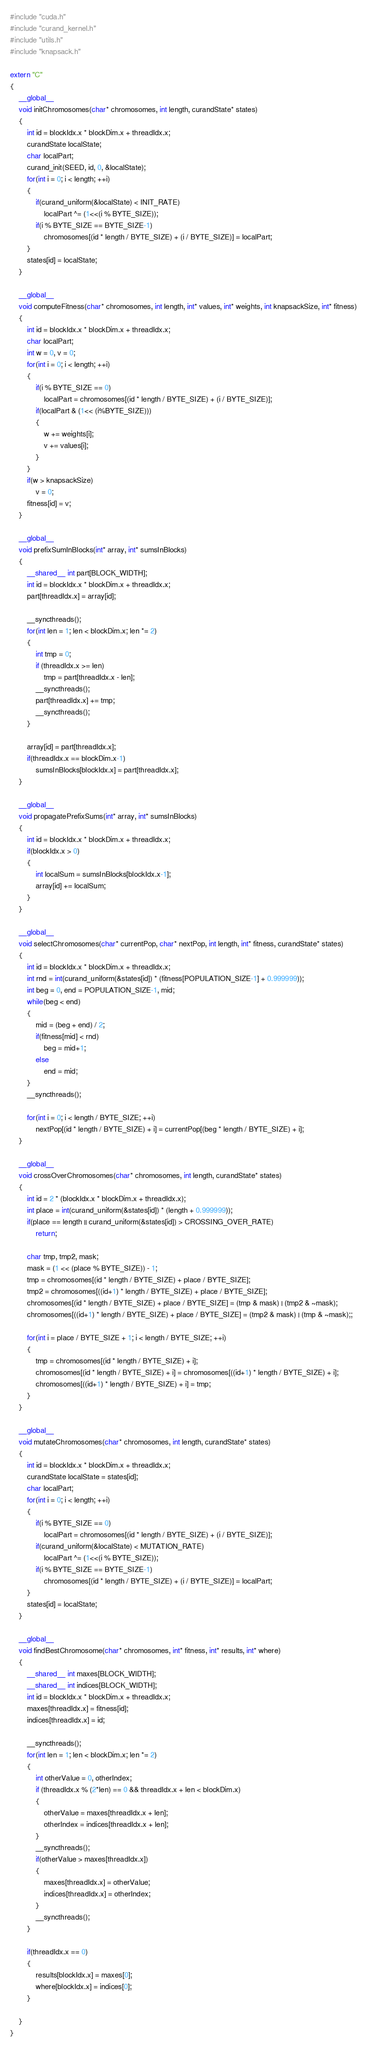Convert code to text. <code><loc_0><loc_0><loc_500><loc_500><_Cuda_>#include "cuda.h"
#include "curand_kernel.h"
#include "utils.h"
#include "knapsack.h"

extern "C"
{
    __global__
    void initChromosomes(char* chromosomes, int length, curandState* states)
    {
        int id = blockIdx.x * blockDim.x + threadIdx.x;
        curandState localState;
        char localPart;
        curand_init(SEED, id, 0, &localState);
        for(int i = 0; i < length; ++i)
        {
            if(curand_uniform(&localState) < INIT_RATE)
                localPart ^= (1<<(i % BYTE_SIZE));
            if(i % BYTE_SIZE == BYTE_SIZE-1)
                chromosomes[(id * length / BYTE_SIZE) + (i / BYTE_SIZE)] = localPart;
        }
        states[id] = localState;
    }

    __global__
    void computeFitness(char* chromosomes, int length, int* values, int* weights, int knapsackSize, int* fitness)
    {
        int id = blockIdx.x * blockDim.x + threadIdx.x;
        char localPart;
        int w = 0, v = 0;
        for(int i = 0; i < length; ++i)
        {
            if(i % BYTE_SIZE == 0)
                localPart = chromosomes[(id * length / BYTE_SIZE) + (i / BYTE_SIZE)];
            if(localPart & (1<< (i%BYTE_SIZE)))
            {
                w += weights[i];
                v += values[i];
            }
        }
        if(w > knapsackSize)
            v = 0;
        fitness[id] = v;
    }

    __global__
    void prefixSumInBlocks(int* array, int* sumsInBlocks)
    {
        __shared__ int part[BLOCK_WIDTH];
        int id = blockIdx.x * blockDim.x + threadIdx.x;
        part[threadIdx.x] = array[id];
        
        __syncthreads();
        for(int len = 1; len < blockDim.x; len *= 2)
        {
            int tmp = 0;
            if (threadIdx.x >= len)
                tmp = part[threadIdx.x - len];
            __syncthreads();
            part[threadIdx.x] += tmp;
            __syncthreads();
        }

        array[id] = part[threadIdx.x];
        if(threadIdx.x == blockDim.x-1)
            sumsInBlocks[blockIdx.x] = part[threadIdx.x];
    }

    __global__
    void propagatePrefixSums(int* array, int* sumsInBlocks)
    {
        int id = blockIdx.x * blockDim.x + threadIdx.x;
        if(blockIdx.x > 0)
        {
            int localSum = sumsInBlocks[blockIdx.x-1];
            array[id] += localSum;
        }
    }

    __global__
    void selectChromosomes(char* currentPop, char* nextPop, int length, int* fitness, curandState* states)
    {
        int id = blockIdx.x * blockDim.x + threadIdx.x;
        int rnd = int(curand_uniform(&states[id]) * (fitness[POPULATION_SIZE-1] + 0.999999));
        int beg = 0, end = POPULATION_SIZE-1, mid;
        while(beg < end)
        {
            mid = (beg + end) / 2;
            if(fitness[mid] < rnd)
                beg = mid+1;
            else
                end = mid;
        }
        __syncthreads();

        for(int i = 0; i < length / BYTE_SIZE; ++i)
            nextPop[(id * length / BYTE_SIZE) + i] = currentPop[(beg * length / BYTE_SIZE) + i];
    }

    __global__
    void crossOverChromosomes(char* chromosomes, int length, curandState* states)
    {
        int id = 2 * (blockIdx.x * blockDim.x + threadIdx.x);
        int place = int(curand_uniform(&states[id]) * (length + 0.999999));
        if(place == length || curand_uniform(&states[id]) > CROSSING_OVER_RATE)
            return;

        char tmp, tmp2, mask;
        mask = (1 << (place % BYTE_SIZE)) - 1;
        tmp = chromosomes[(id * length / BYTE_SIZE) + place / BYTE_SIZE];
        tmp2 = chromosomes[((id+1) * length / BYTE_SIZE) + place / BYTE_SIZE];
        chromosomes[(id * length / BYTE_SIZE) + place / BYTE_SIZE] = (tmp & mask) | (tmp2 & ~mask);
        chromosomes[((id+1) * length / BYTE_SIZE) + place / BYTE_SIZE] = (tmp2 & mask) | (tmp & ~mask);;

        for(int i = place / BYTE_SIZE + 1; i < length / BYTE_SIZE; ++i)
        {
            tmp = chromosomes[(id * length / BYTE_SIZE) + i];
            chromosomes[(id * length / BYTE_SIZE) + i] = chromosomes[((id+1) * length / BYTE_SIZE) + i];
            chromosomes[((id+1) * length / BYTE_SIZE) + i] = tmp;
        }
    }

    __global__
    void mutateChromosomes(char* chromosomes, int length, curandState* states)
    {
        int id = blockIdx.x * blockDim.x + threadIdx.x;
        curandState localState = states[id];
        char localPart;
        for(int i = 0; i < length; ++i)
        {
            if(i % BYTE_SIZE == 0)
                localPart = chromosomes[(id * length / BYTE_SIZE) + (i / BYTE_SIZE)];
            if(curand_uniform(&localState) < MUTATION_RATE)
                localPart ^= (1<<(i % BYTE_SIZE));
            if(i % BYTE_SIZE == BYTE_SIZE-1)
                chromosomes[(id * length / BYTE_SIZE) + (i / BYTE_SIZE)] = localPart;
        }
        states[id] = localState;
    }

    __global__
    void findBestChromosome(char* chromosomes, int* fitness, int* results, int* where)
    {
        __shared__ int maxes[BLOCK_WIDTH];
        __shared__ int indices[BLOCK_WIDTH];
        int id = blockIdx.x * blockDim.x + threadIdx.x;
        maxes[threadIdx.x] = fitness[id];
        indices[threadIdx.x] = id;
        
        __syncthreads();
        for(int len = 1; len < blockDim.x; len *= 2)
        {
            int otherValue = 0, otherIndex;
            if (threadIdx.x % (2*len) == 0 && threadIdx.x + len < blockDim.x)
            {
                otherValue = maxes[threadIdx.x + len];
                otherIndex = indices[threadIdx.x + len];
            }
            __syncthreads();
            if(otherValue > maxes[threadIdx.x])
            {
                maxes[threadIdx.x] = otherValue;
                indices[threadIdx.x] = otherIndex;
            }
            __syncthreads();
        }

        if(threadIdx.x == 0)
        {
            results[blockIdx.x] = maxes[0];
            where[blockIdx.x] = indices[0];
        }

    }
}
</code> 